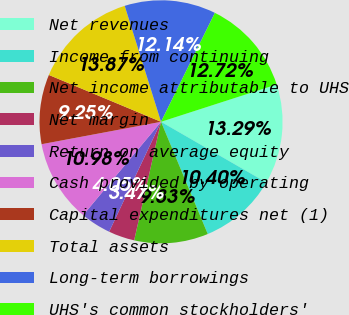Convert chart to OTSL. <chart><loc_0><loc_0><loc_500><loc_500><pie_chart><fcel>Net revenues<fcel>Income from continuing<fcel>Net income attributable to UHS<fcel>Net margin<fcel>Return on average equity<fcel>Cash provided by operating<fcel>Capital expenditures net (1)<fcel>Total assets<fcel>Long-term borrowings<fcel>UHS's common stockholders'<nl><fcel>13.29%<fcel>10.4%<fcel>9.83%<fcel>3.47%<fcel>4.05%<fcel>10.98%<fcel>9.25%<fcel>13.87%<fcel>12.14%<fcel>12.72%<nl></chart> 